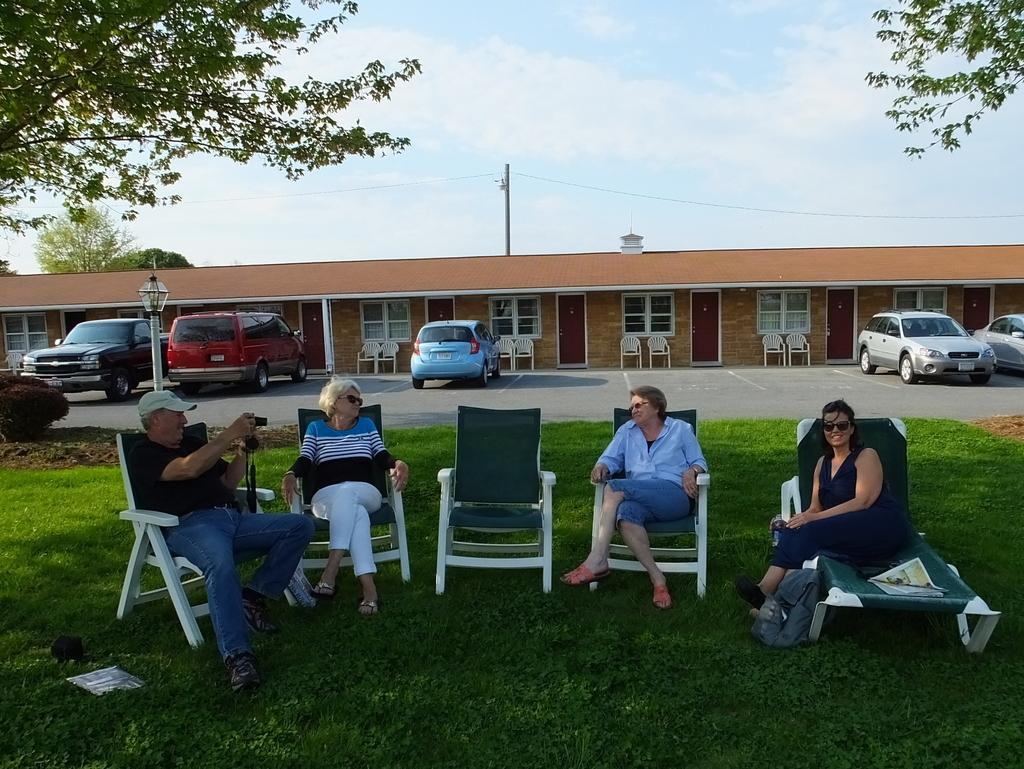Could you give a brief overview of what you see in this image? In this image we can see person sitting on the chairs. On the left side of the image there is a person sitting on the chair and holding a camera. In the background there are cars, chairs, building, pole, tree, sky and clouds. 